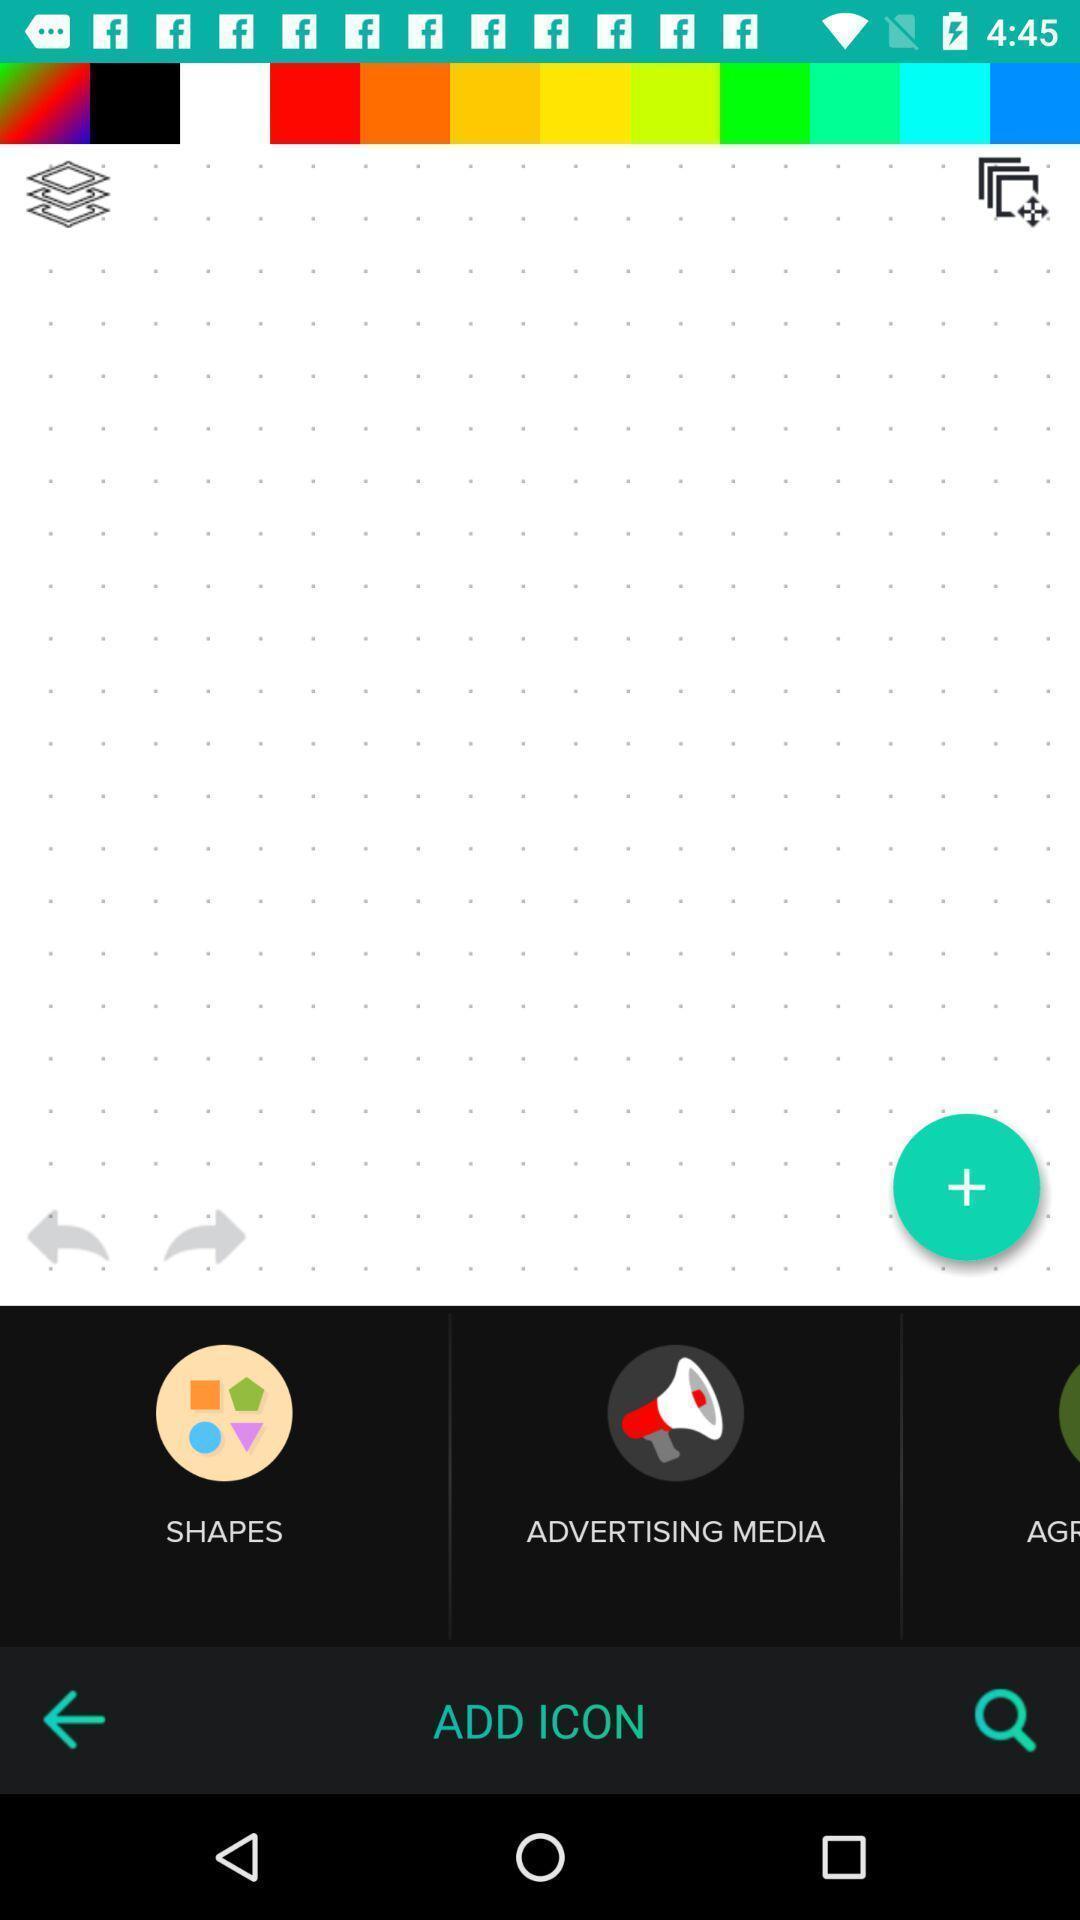Describe this image in words. Screen displaying shapes and add icon options. 